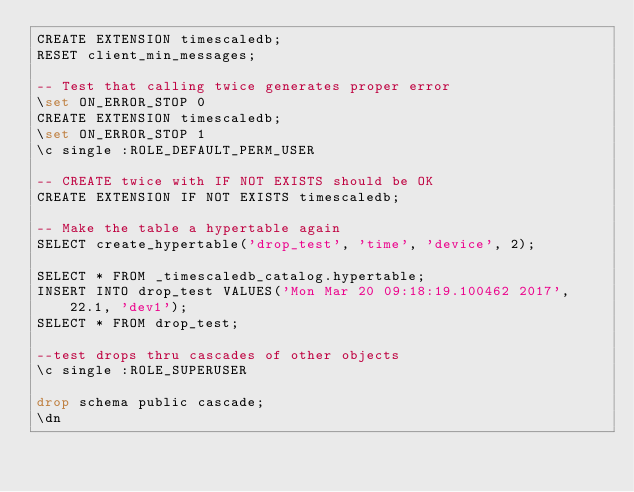<code> <loc_0><loc_0><loc_500><loc_500><_SQL_>CREATE EXTENSION timescaledb;
RESET client_min_messages;

-- Test that calling twice generates proper error
\set ON_ERROR_STOP 0
CREATE EXTENSION timescaledb;
\set ON_ERROR_STOP 1
\c single :ROLE_DEFAULT_PERM_USER

-- CREATE twice with IF NOT EXISTS should be OK
CREATE EXTENSION IF NOT EXISTS timescaledb;

-- Make the table a hypertable again
SELECT create_hypertable('drop_test', 'time', 'device', 2);

SELECT * FROM _timescaledb_catalog.hypertable;
INSERT INTO drop_test VALUES('Mon Mar 20 09:18:19.100462 2017', 22.1, 'dev1');
SELECT * FROM drop_test;

--test drops thru cascades of other objects
\c single :ROLE_SUPERUSER

drop schema public cascade;
\dn
</code> 